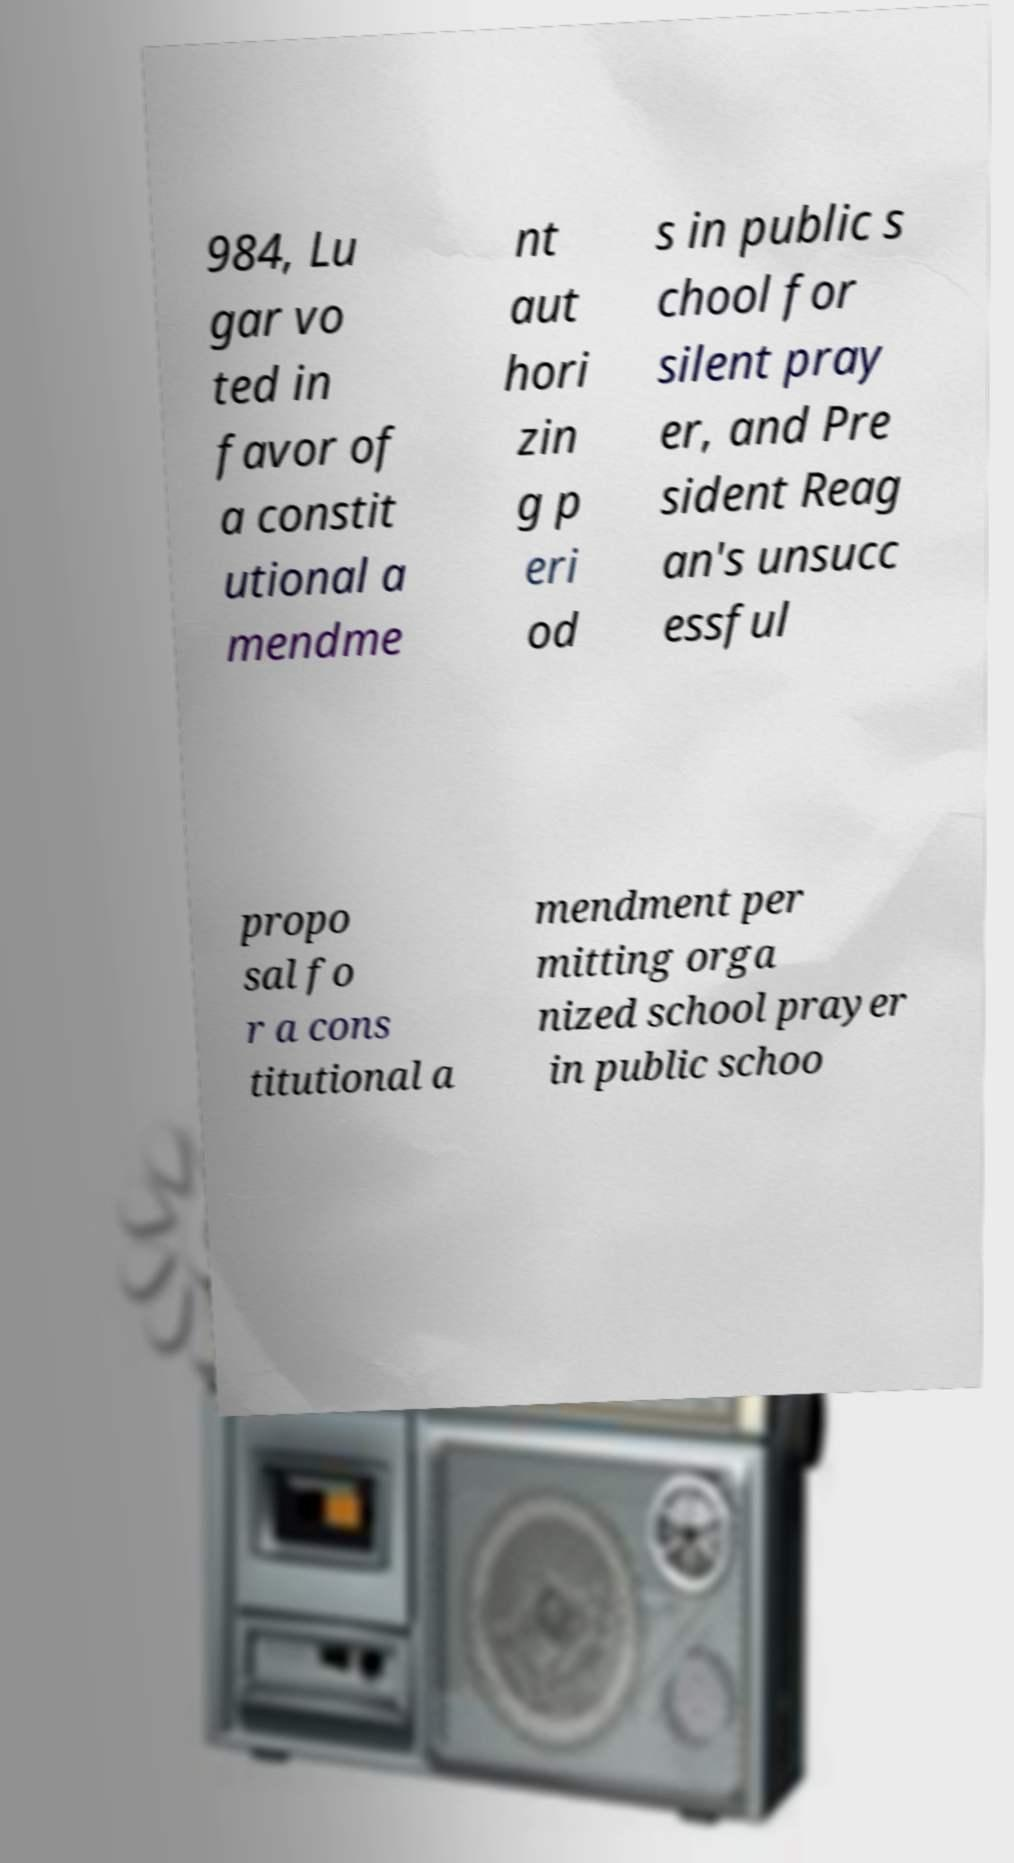Could you extract and type out the text from this image? 984, Lu gar vo ted in favor of a constit utional a mendme nt aut hori zin g p eri od s in public s chool for silent pray er, and Pre sident Reag an's unsucc essful propo sal fo r a cons titutional a mendment per mitting orga nized school prayer in public schoo 